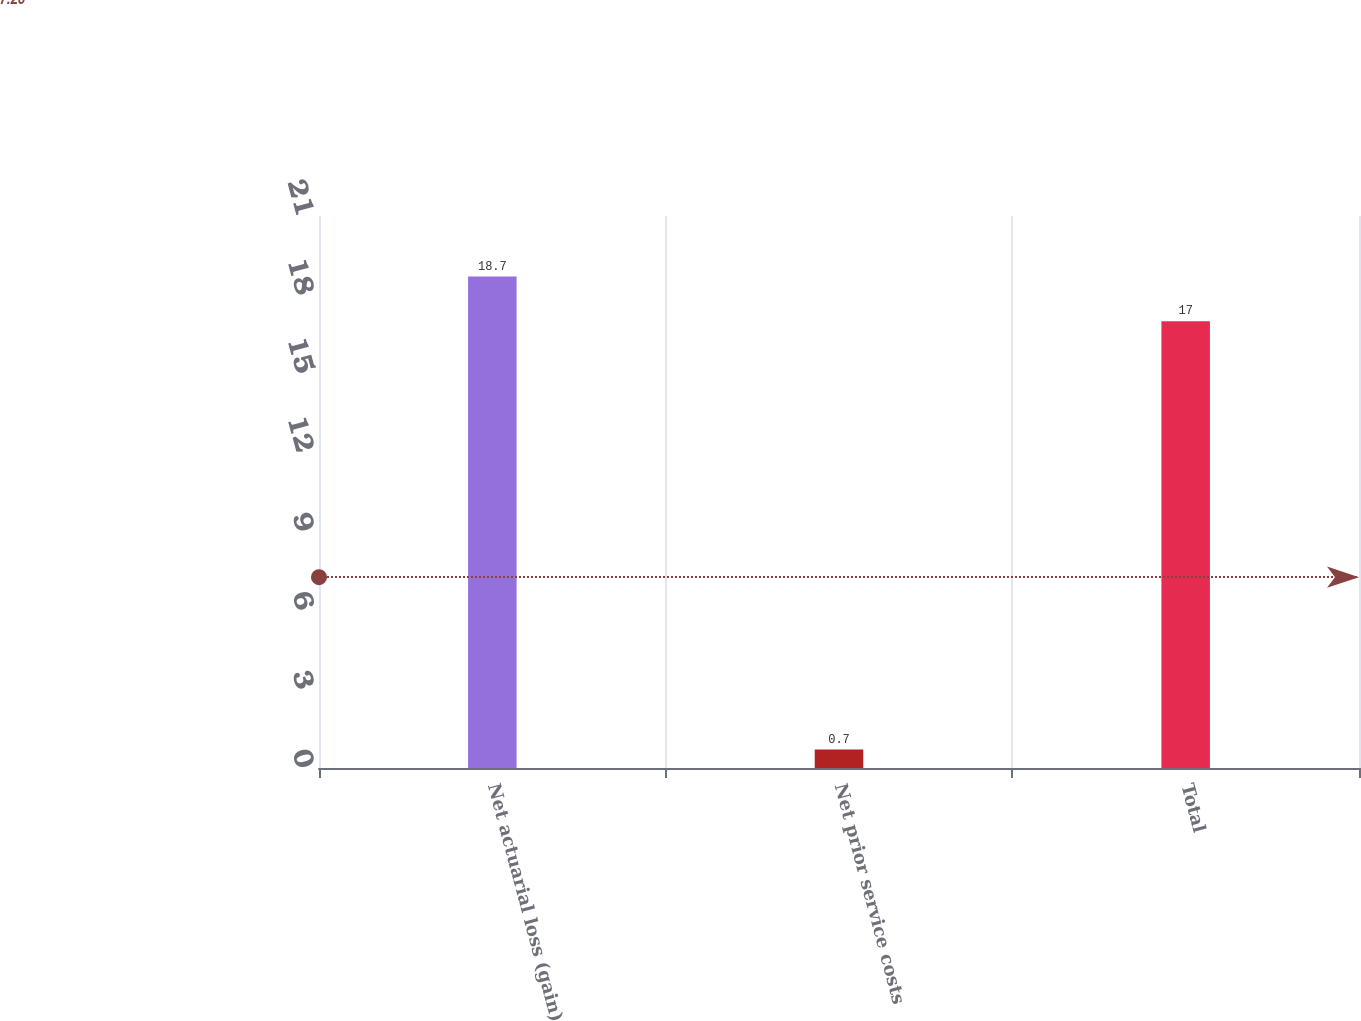Convert chart to OTSL. <chart><loc_0><loc_0><loc_500><loc_500><bar_chart><fcel>Net actuarial loss (gain)<fcel>Net prior service costs<fcel>Total<nl><fcel>18.7<fcel>0.7<fcel>17<nl></chart> 